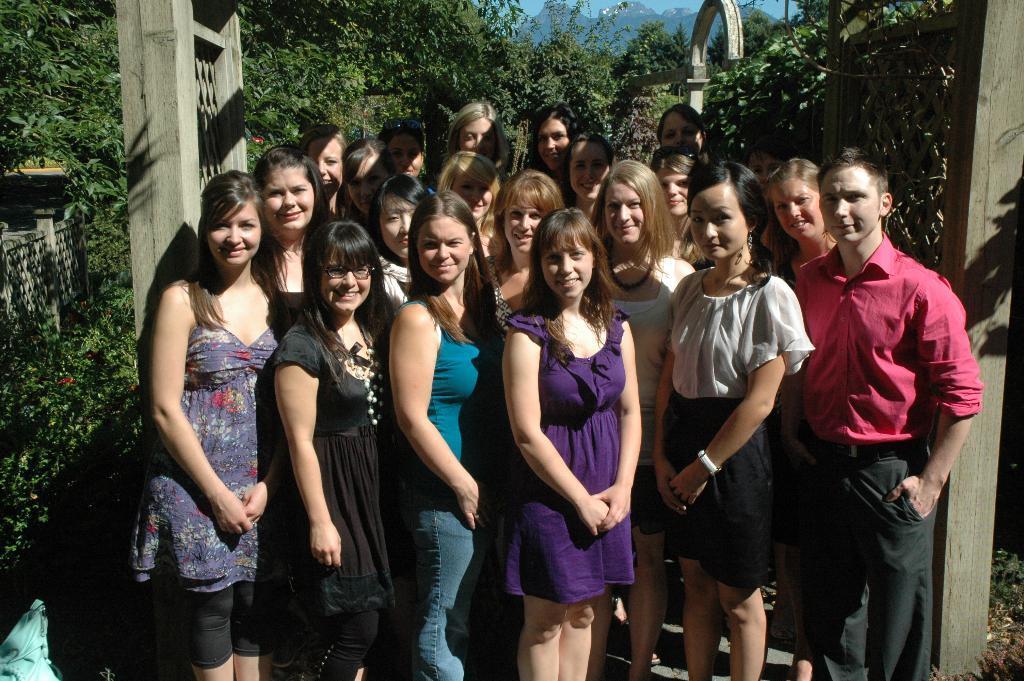How would you summarize this image in a sentence or two? In this image I can see a group of people standing and posing for the picture. I can see trees and plants behind them and mountains at the top of the image. 